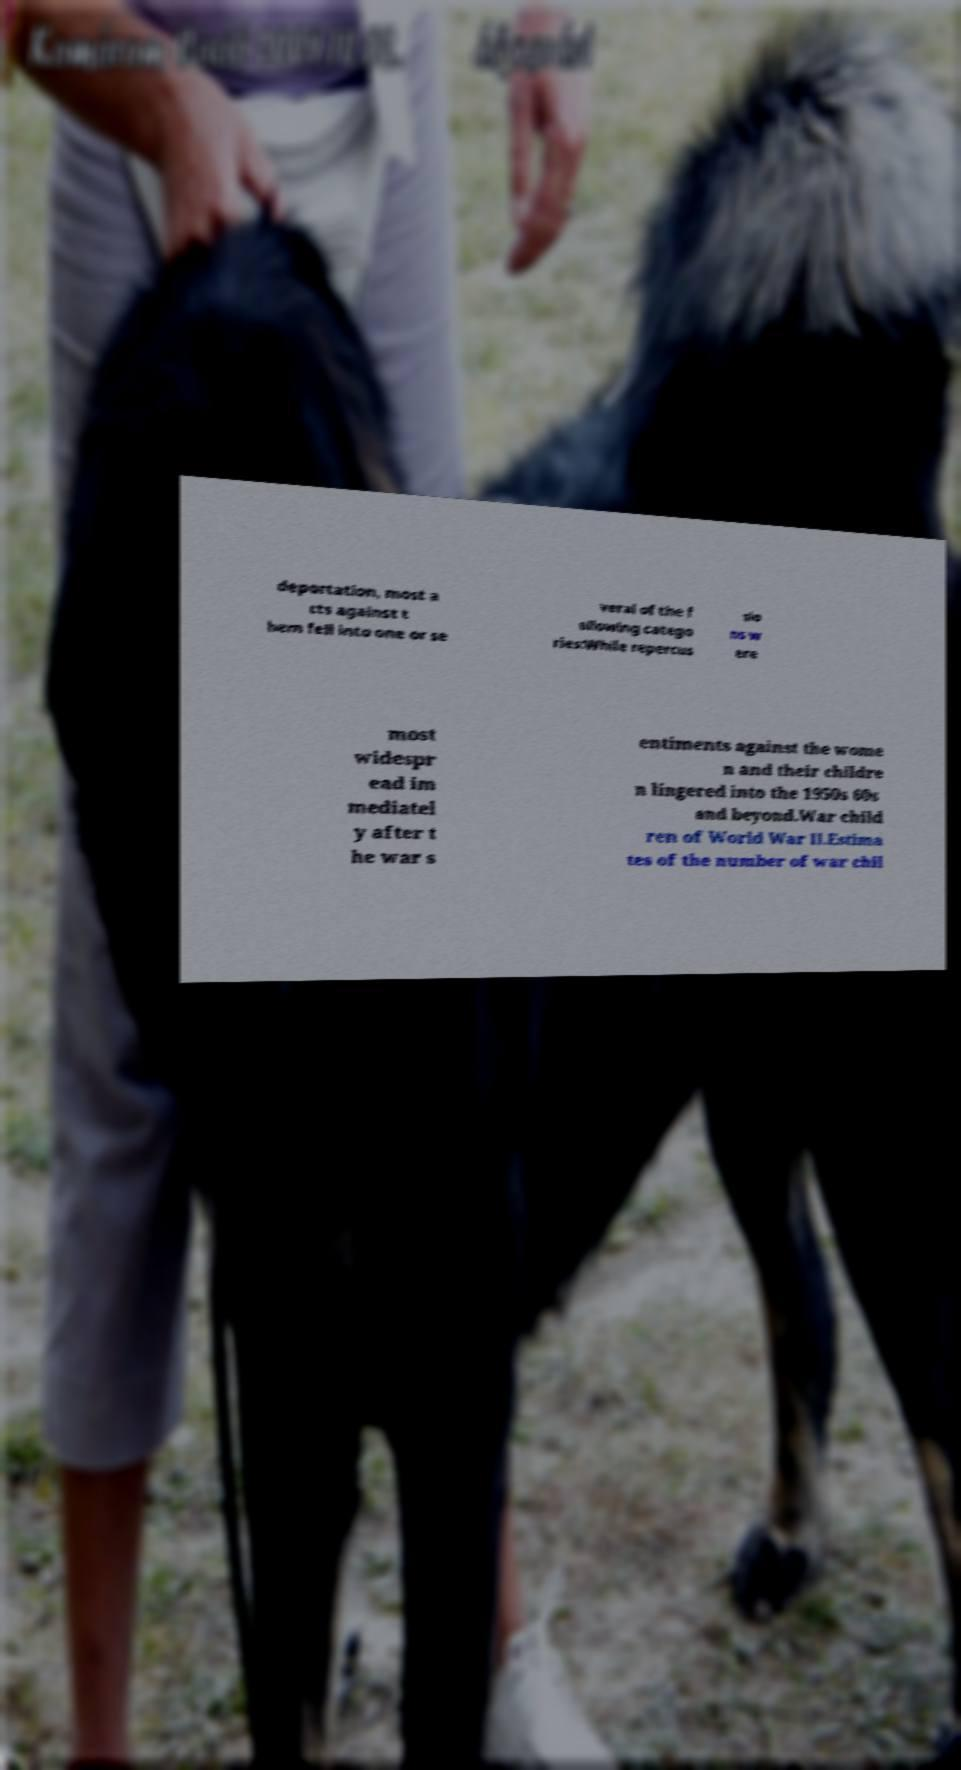What messages or text are displayed in this image? I need them in a readable, typed format. deportation, most a cts against t hem fell into one or se veral of the f ollowing catego ries:While repercus sio ns w ere most widespr ead im mediatel y after t he war s entiments against the wome n and their childre n lingered into the 1950s 60s and beyond.War child ren of World War II.Estima tes of the number of war chil 